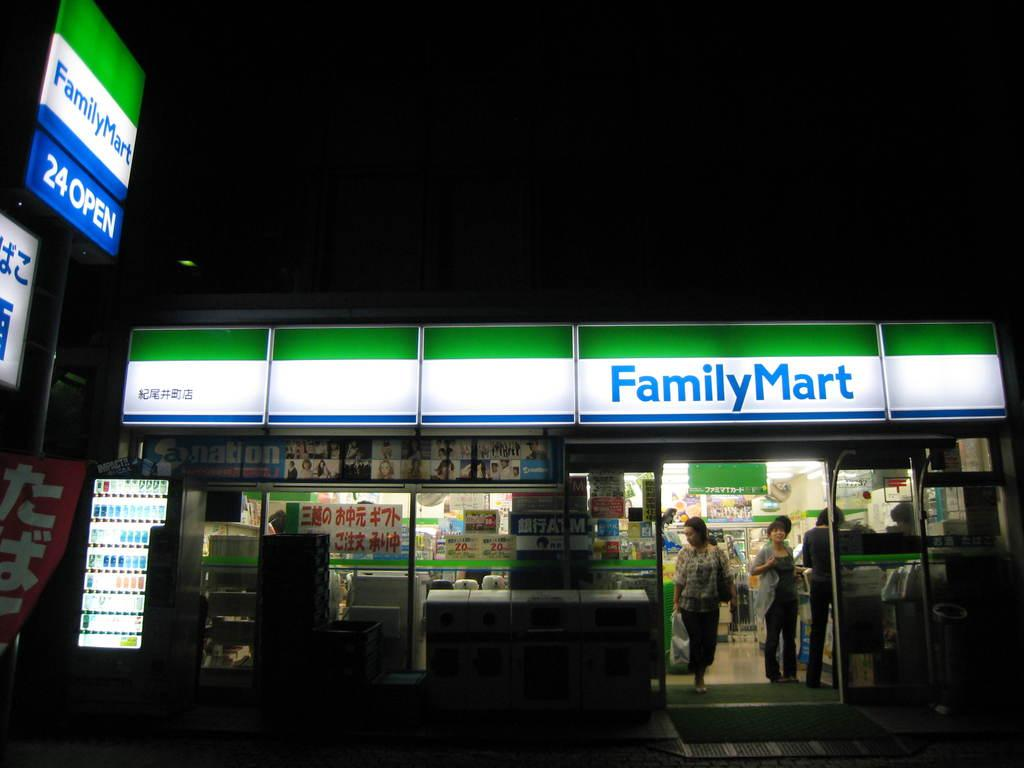<image>
Write a terse but informative summary of the picture. Two people walking out of the store that has Family Mart in blue letters at the top. 